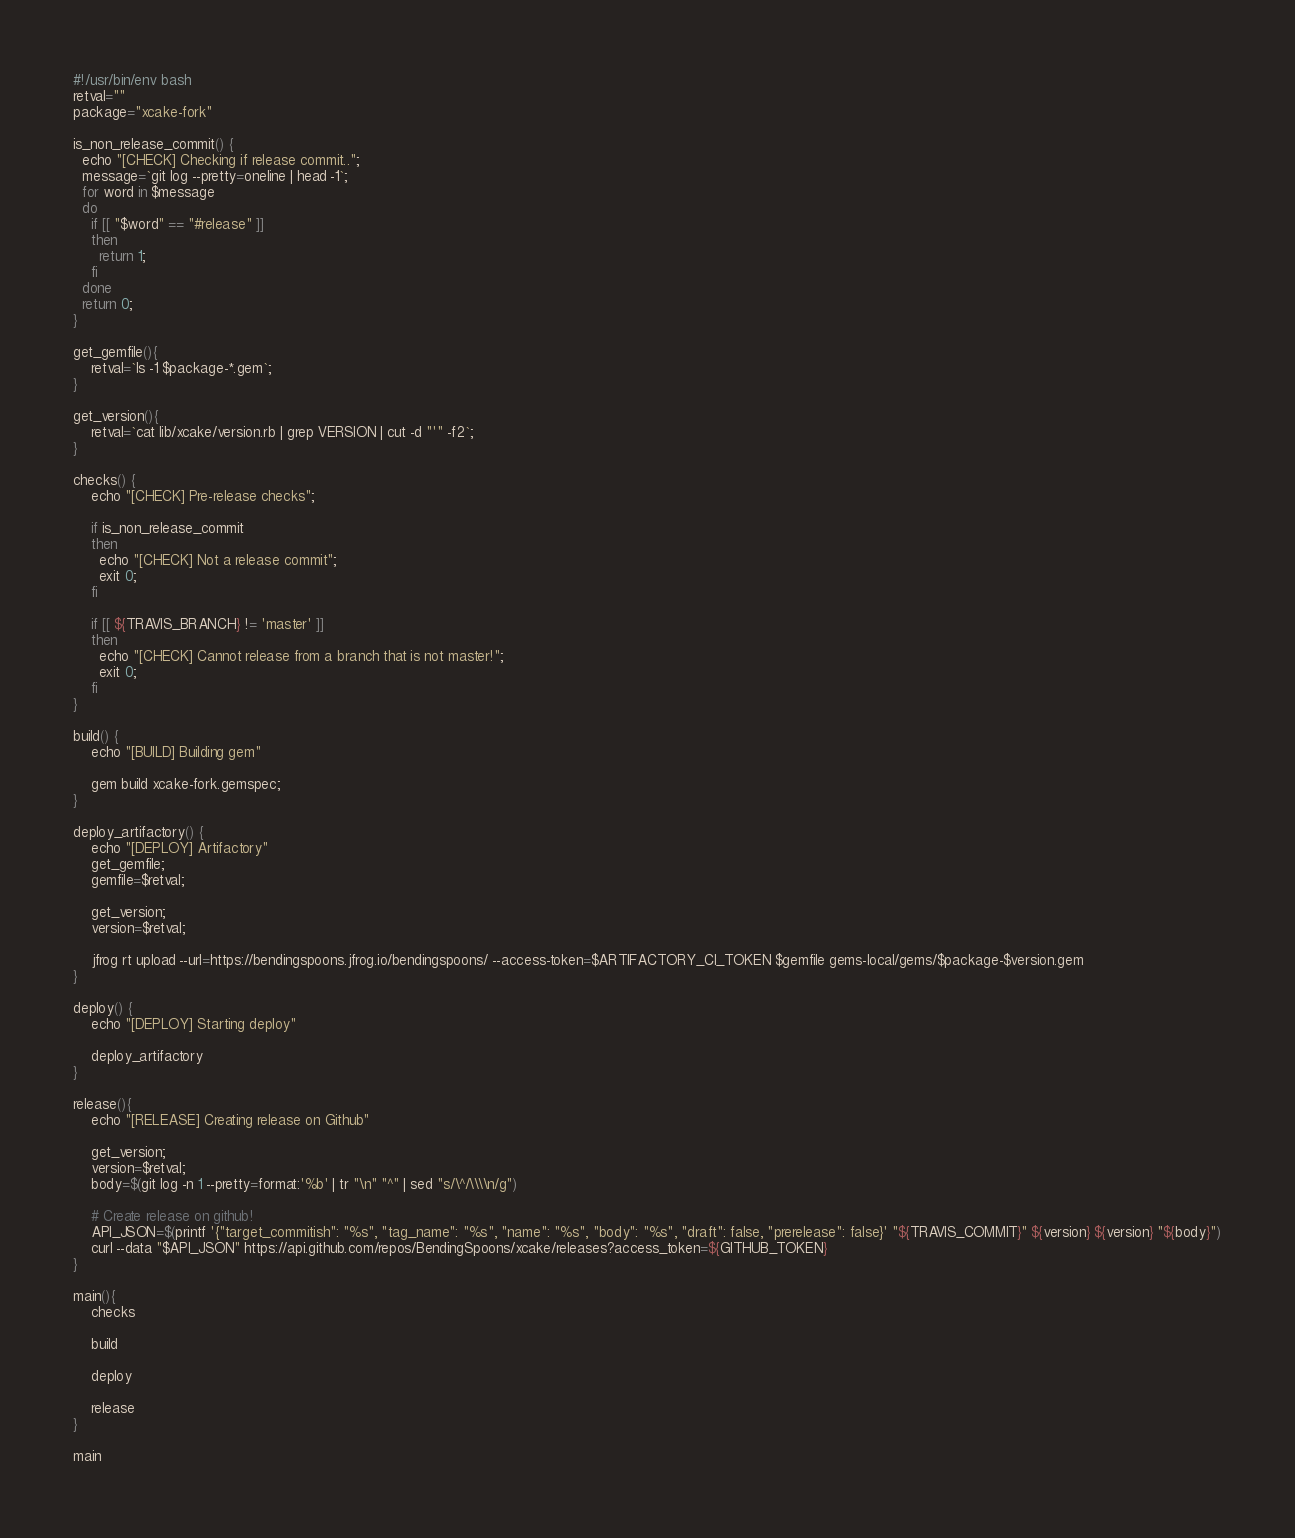Convert code to text. <code><loc_0><loc_0><loc_500><loc_500><_Bash_>#!/usr/bin/env bash
retval=""
package="xcake-fork"

is_non_release_commit() {
  echo "[CHECK] Checking if release commit..";
  message=`git log --pretty=oneline | head -1`;
  for word in $message
  do
    if [[ "$word" == "#release" ]] 
    then
      return 1;
    fi
  done
  return 0;
}

get_gemfile(){
    retval=`ls -1 $package-*.gem`;
}

get_version(){
    retval=`cat lib/xcake/version.rb | grep VERSION | cut -d "'" -f2`;
}

checks() {
    echo "[CHECK] Pre-release checks";

    if is_non_release_commit
    then
      echo "[CHECK] Not a release commit";
      exit 0;
    fi

    if [[ ${TRAVIS_BRANCH} != 'master' ]]
    then
      echo "[CHECK] Cannot release from a branch that is not master!";
      exit 0;
    fi
}

build() {
    echo "[BUILD] Building gem"

    gem build xcake-fork.gemspec;
}

deploy_artifactory() {
    echo "[DEPLOY] Artifactory"
    get_gemfile;
    gemfile=$retval;

    get_version;
    version=$retval;

    jfrog rt upload --url=https://bendingspoons.jfrog.io/bendingspoons/ --access-token=$ARTIFACTORY_CI_TOKEN $gemfile gems-local/gems/$package-$version.gem
}

deploy() {
    echo "[DEPLOY] Starting deploy"

    deploy_artifactory
}

release(){
    echo "[RELEASE] Creating release on Github"

    get_version;
    version=$retval;
    body=$(git log -n 1 --pretty=format:'%b' | tr "\n" "^" | sed "s/\^/\\\\n/g")

    # Create release on github!
    API_JSON=$(printf '{"target_commitish": "%s", "tag_name": "%s", "name": "%s", "body": "%s", "draft": false, "prerelease": false}' "${TRAVIS_COMMIT}" ${version} ${version} "${body}")
    curl --data "$API_JSON" https://api.github.com/repos/BendingSpoons/xcake/releases?access_token=${GITHUB_TOKEN}
}

main(){
    checks

    build

    deploy

    release
}

main
</code> 